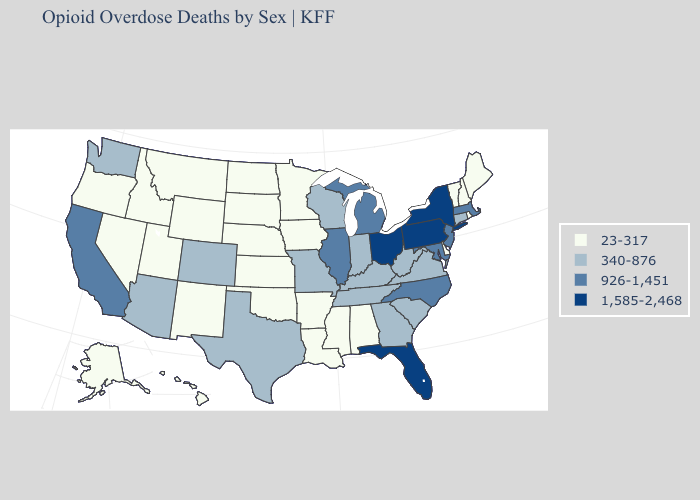Does Delaware have the lowest value in the South?
Short answer required. Yes. What is the highest value in states that border West Virginia?
Concise answer only. 1,585-2,468. Among the states that border Illinois , does Iowa have the lowest value?
Concise answer only. Yes. Which states hav the highest value in the Northeast?
Write a very short answer. New York, Pennsylvania. Among the states that border Rhode Island , does Connecticut have the highest value?
Concise answer only. No. What is the value of Illinois?
Keep it brief. 926-1,451. Among the states that border Iowa , does Minnesota have the lowest value?
Give a very brief answer. Yes. Does Indiana have a higher value than Oregon?
Answer briefly. Yes. What is the highest value in states that border Wyoming?
Be succinct. 340-876. Name the states that have a value in the range 1,585-2,468?
Concise answer only. Florida, New York, Ohio, Pennsylvania. Does Utah have the highest value in the USA?
Short answer required. No. What is the value of Alaska?
Quick response, please. 23-317. Does the map have missing data?
Answer briefly. No. What is the lowest value in the USA?
Answer briefly. 23-317. Among the states that border Alabama , does Florida have the lowest value?
Give a very brief answer. No. 